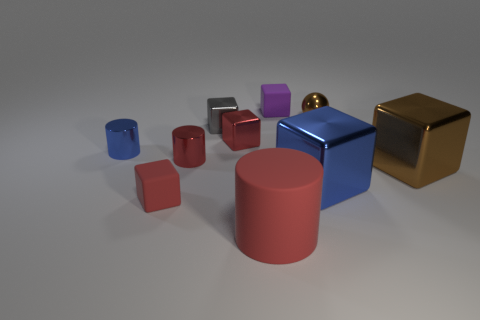There is a cube that is in front of the brown metal block and on the left side of the large blue shiny thing; what is its color? red 